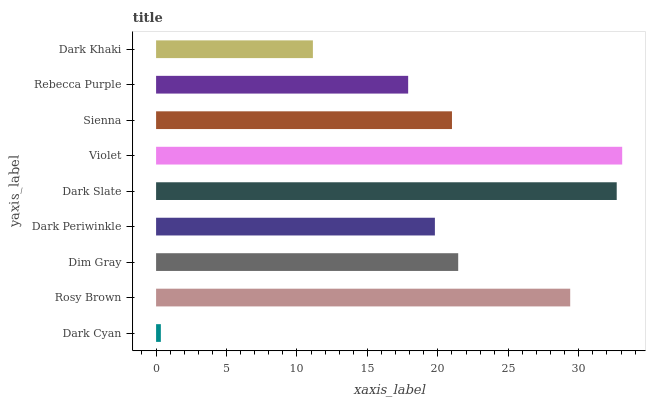Is Dark Cyan the minimum?
Answer yes or no. Yes. Is Violet the maximum?
Answer yes or no. Yes. Is Rosy Brown the minimum?
Answer yes or no. No. Is Rosy Brown the maximum?
Answer yes or no. No. Is Rosy Brown greater than Dark Cyan?
Answer yes or no. Yes. Is Dark Cyan less than Rosy Brown?
Answer yes or no. Yes. Is Dark Cyan greater than Rosy Brown?
Answer yes or no. No. Is Rosy Brown less than Dark Cyan?
Answer yes or no. No. Is Sienna the high median?
Answer yes or no. Yes. Is Sienna the low median?
Answer yes or no. Yes. Is Dark Periwinkle the high median?
Answer yes or no. No. Is Dark Cyan the low median?
Answer yes or no. No. 